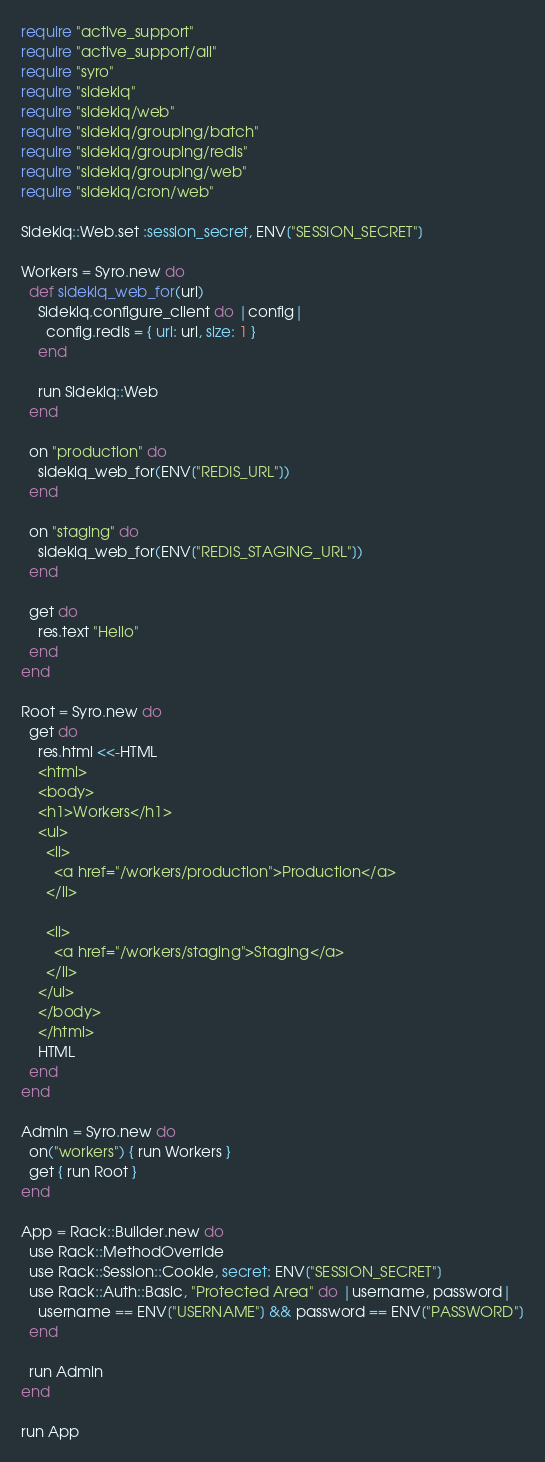<code> <loc_0><loc_0><loc_500><loc_500><_Ruby_>require "active_support"
require "active_support/all"
require "syro"
require "sidekiq"
require "sidekiq/web"
require "sidekiq/grouping/batch"
require "sidekiq/grouping/redis"
require "sidekiq/grouping/web"
require "sidekiq/cron/web"

Sidekiq::Web.set :session_secret, ENV["SESSION_SECRET"]

Workers = Syro.new do
  def sidekiq_web_for(url)
    Sidekiq.configure_client do |config|
      config.redis = { url: url, size: 1 }
    end

    run Sidekiq::Web
  end

  on "production" do
    sidekiq_web_for(ENV["REDIS_URL"])
  end

  on "staging" do
    sidekiq_web_for(ENV["REDIS_STAGING_URL"])
  end

  get do
    res.text "Hello"
  end
end

Root = Syro.new do
  get do
    res.html <<-HTML
    <html>
    <body>
    <h1>Workers</h1>
    <ul>
      <li>
        <a href="/workers/production">Production</a>
      </li>

      <li>
        <a href="/workers/staging">Staging</a>
      </li>
    </ul>
    </body>
    </html>
    HTML
  end
end

Admin = Syro.new do
  on("workers") { run Workers }
  get { run Root }
end

App = Rack::Builder.new do
  use Rack::MethodOverride
  use Rack::Session::Cookie, secret: ENV["SESSION_SECRET"]
  use Rack::Auth::Basic, "Protected Area" do |username, password|
    username == ENV["USERNAME"] && password == ENV["PASSWORD"]
  end

  run Admin
end

run App
</code> 